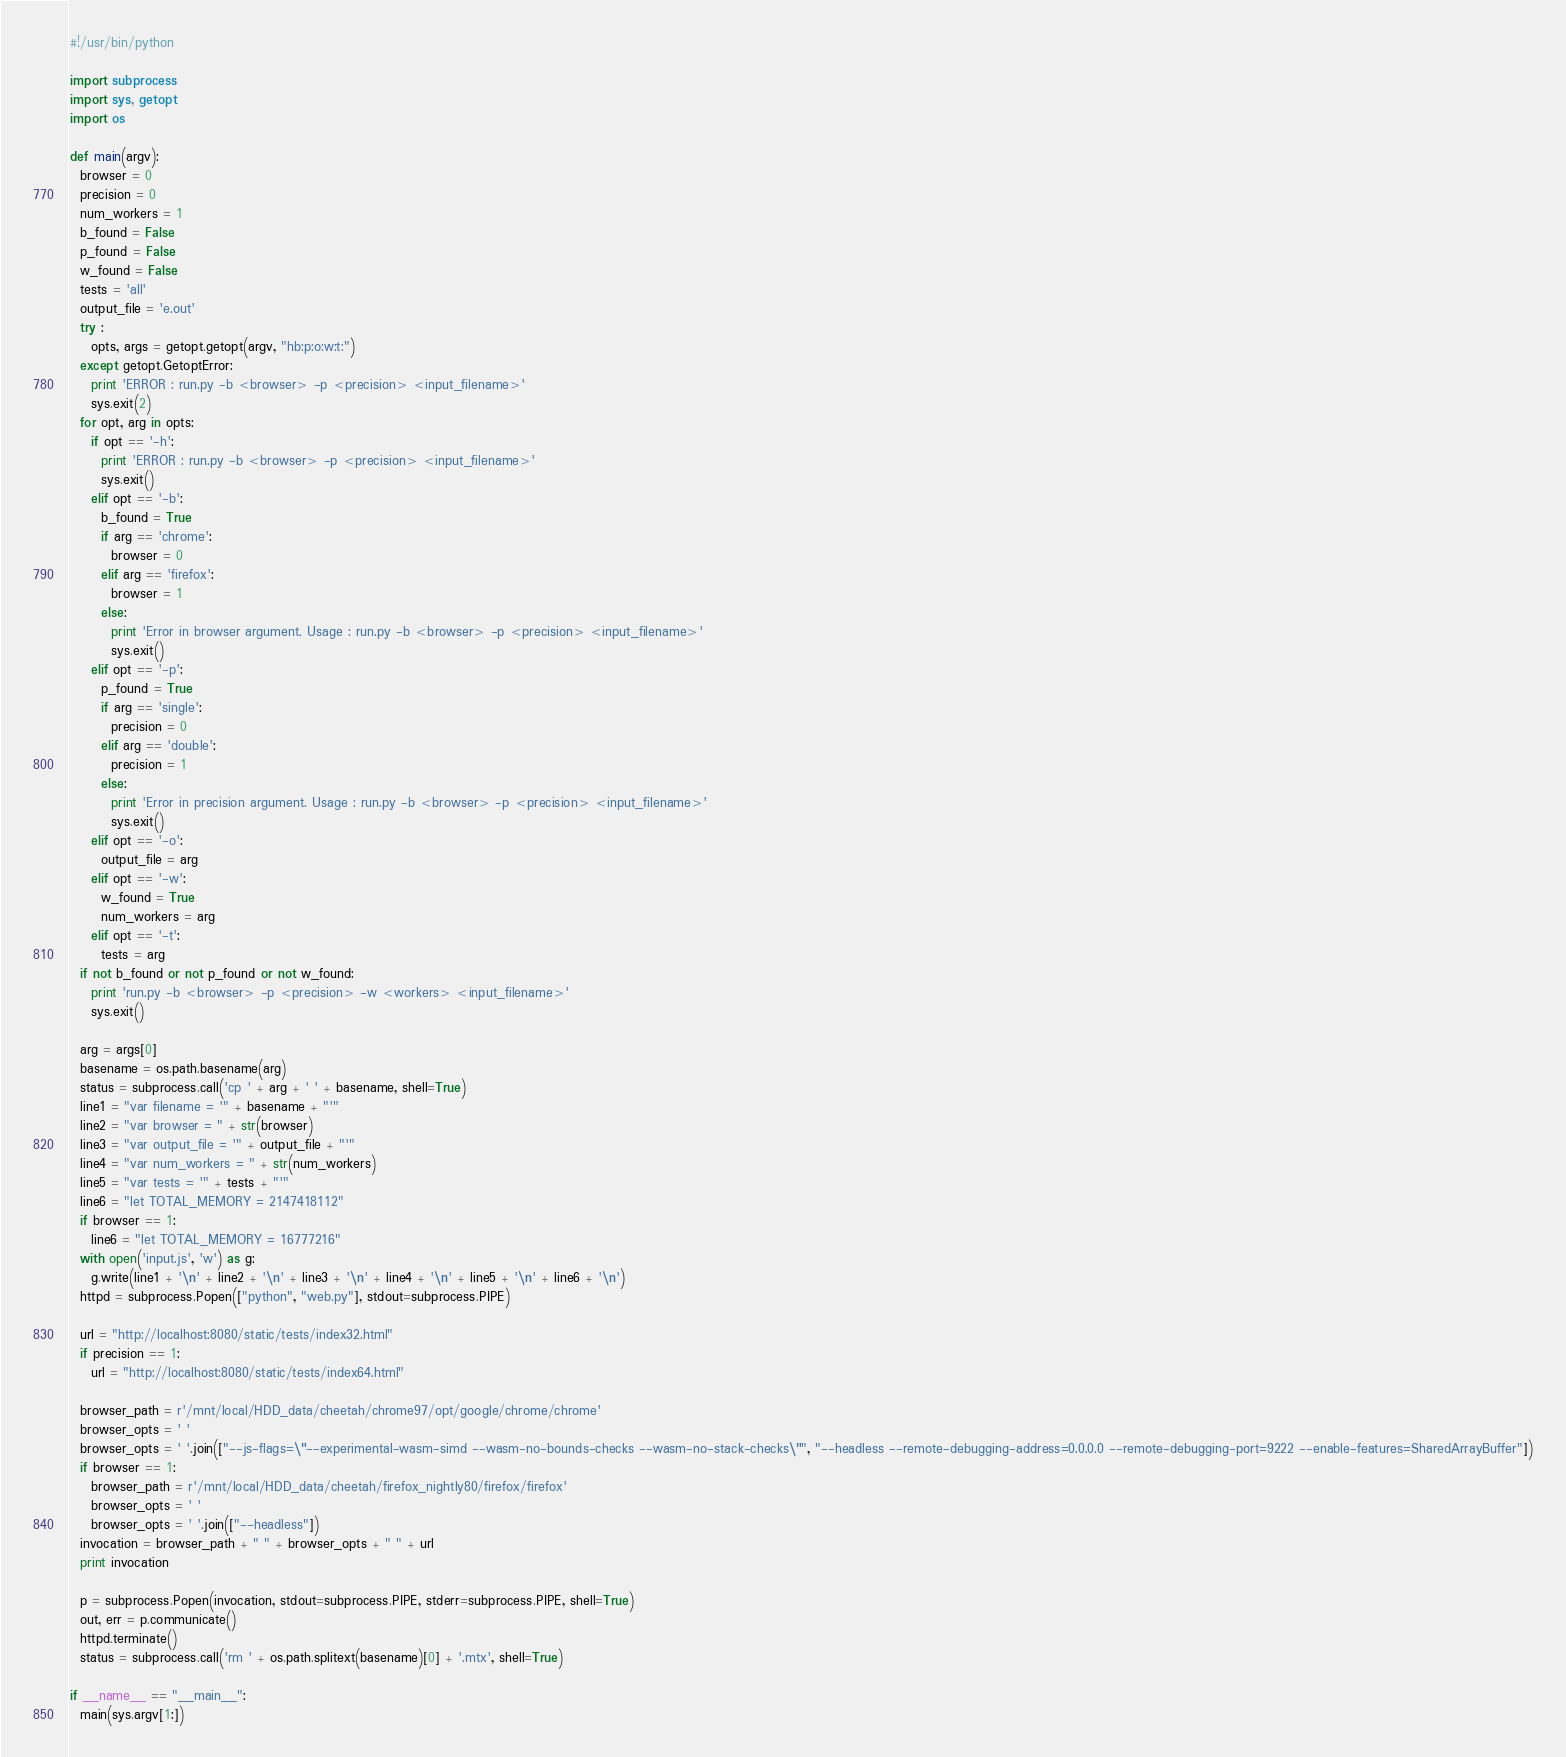Convert code to text. <code><loc_0><loc_0><loc_500><loc_500><_Python_>#!/usr/bin/python

import subprocess
import sys, getopt
import os

def main(argv):
  browser = 0
  precision = 0
  num_workers = 1
  b_found = False
  p_found = False
  w_found = False
  tests = 'all'
  output_file = 'e.out'
  try :
    opts, args = getopt.getopt(argv, "hb:p:o:w:t:")
  except getopt.GetoptError:
    print 'ERROR : run.py -b <browser> -p <precision> <input_filename>'
    sys.exit(2)
  for opt, arg in opts:
    if opt == '-h':
      print 'ERROR : run.py -b <browser> -p <precision> <input_filename>'
      sys.exit()
    elif opt == '-b':
      b_found = True
      if arg == 'chrome':
        browser = 0
      elif arg == 'firefox':
        browser = 1
      else:
        print 'Error in browser argument. Usage : run.py -b <browser> -p <precision> <input_filename>'
        sys.exit()
    elif opt == '-p':
      p_found = True
      if arg == 'single':
        precision = 0
      elif arg == 'double':
        precision = 1
      else:
        print 'Error in precision argument. Usage : run.py -b <browser> -p <precision> <input_filename>'
        sys.exit()
    elif opt == '-o':
      output_file = arg
    elif opt == '-w':
      w_found = True
      num_workers = arg
    elif opt == '-t':
      tests = arg
  if not b_found or not p_found or not w_found:
    print 'run.py -b <browser> -p <precision> -w <workers> <input_filename>'
    sys.exit()

  arg = args[0] 
  basename = os.path.basename(arg)
  status = subprocess.call('cp ' + arg + ' ' + basename, shell=True)
  line1 = "var filename = '" + basename + "'"  
  line2 = "var browser = " + str(browser)
  line3 = "var output_file = '" + output_file + "'"
  line4 = "var num_workers = " + str(num_workers)
  line5 = "var tests = '" + tests + "'"
  line6 = "let TOTAL_MEMORY = 2147418112"
  if browser == 1:
    line6 = "let TOTAL_MEMORY = 16777216" 
  with open('input.js', 'w') as g:
    g.write(line1 + '\n' + line2 + '\n' + line3 + '\n' + line4 + '\n' + line5 + '\n' + line6 + '\n')
  httpd = subprocess.Popen(["python", "web.py"], stdout=subprocess.PIPE)

  url = "http://localhost:8080/static/tests/index32.html"
  if precision == 1:
    url = "http://localhost:8080/static/tests/index64.html"

  browser_path = r'/mnt/local/HDD_data/cheetah/chrome97/opt/google/chrome/chrome'
  browser_opts = ' '
  browser_opts = ' '.join(["--js-flags=\"--experimental-wasm-simd --wasm-no-bounds-checks --wasm-no-stack-checks\"", "--headless --remote-debugging-address=0.0.0.0 --remote-debugging-port=9222 --enable-features=SharedArrayBuffer"])
  if browser == 1:
    browser_path = r'/mnt/local/HDD_data/cheetah/firefox_nightly80/firefox/firefox'
    browser_opts = ' '
    browser_opts = ' '.join(["--headless"])
  invocation = browser_path + " " + browser_opts + " " + url 
  print invocation

  p = subprocess.Popen(invocation, stdout=subprocess.PIPE, stderr=subprocess.PIPE, shell=True)
  out, err = p.communicate()
  httpd.terminate()
  status = subprocess.call('rm ' + os.path.splitext(basename)[0] + '.mtx', shell=True)

if __name__ == "__main__":
  main(sys.argv[1:])

</code> 